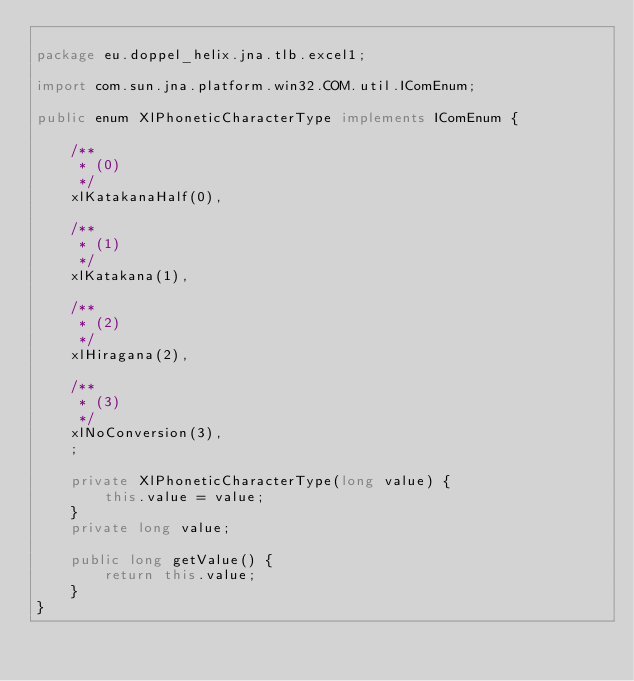<code> <loc_0><loc_0><loc_500><loc_500><_Java_>
package eu.doppel_helix.jna.tlb.excel1;

import com.sun.jna.platform.win32.COM.util.IComEnum;

public enum XlPhoneticCharacterType implements IComEnum {
    
    /**
     * (0)
     */
    xlKatakanaHalf(0),
    
    /**
     * (1)
     */
    xlKatakana(1),
    
    /**
     * (2)
     */
    xlHiragana(2),
    
    /**
     * (3)
     */
    xlNoConversion(3),
    ;

    private XlPhoneticCharacterType(long value) {
        this.value = value;
    }
    private long value;

    public long getValue() {
        return this.value;
    }
}</code> 